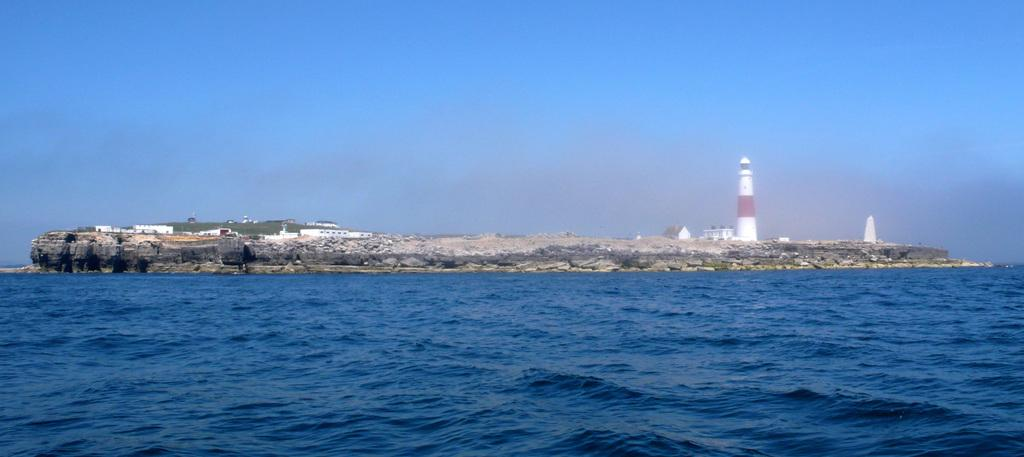What is one of the natural elements present in the image? There is water in the image. What type of geological formation can be seen in the image? There is a rock in the image. What type of man-made structure is present in the image? There is a tower in the image. What type of residential buildings are visible in the image? There are houses in the image. What is visible in the background of the image? The sky is visible in the background of the image. Where is the heart-shaped rock located in the image? There is no heart-shaped rock present in the image. How does the tower maintain its balance in the image? The tower does not need to maintain its balance in the image; it is a static structure. 